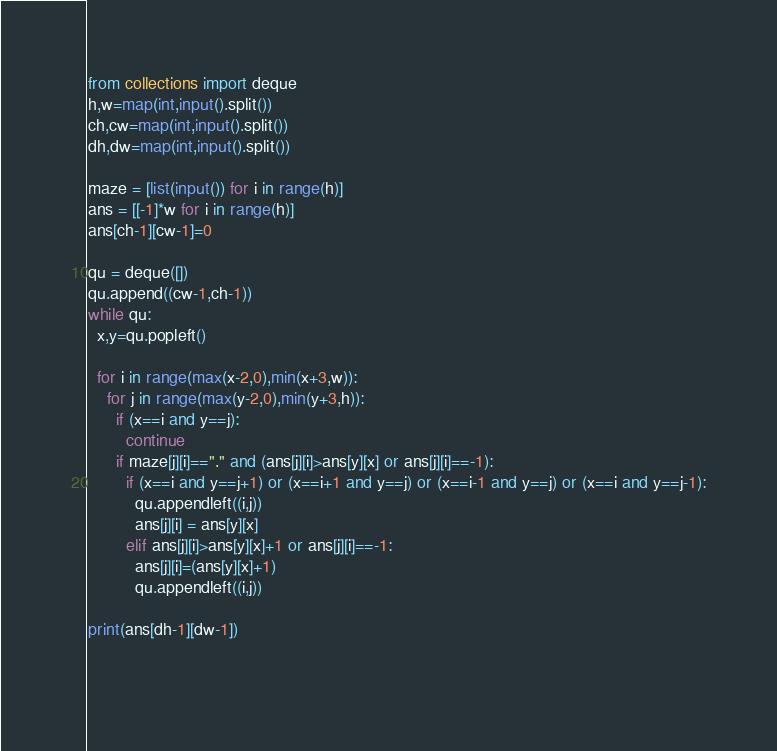<code> <loc_0><loc_0><loc_500><loc_500><_Python_>from collections import deque
h,w=map(int,input().split())
ch,cw=map(int,input().split())
dh,dw=map(int,input().split())

maze = [list(input()) for i in range(h)]
ans = [[-1]*w for i in range(h)]
ans[ch-1][cw-1]=0

qu = deque([])
qu.append((cw-1,ch-1))
while qu:
  x,y=qu.popleft()

  for i in range(max(x-2,0),min(x+3,w)):
    for j in range(max(y-2,0),min(y+3,h)):
      if (x==i and y==j):
        continue
      if maze[j][i]=="." and (ans[j][i]>ans[y][x] or ans[j][i]==-1):
        if (x==i and y==j+1) or (x==i+1 and y==j) or (x==i-1 and y==j) or (x==i and y==j-1):
          qu.appendleft((i,j))
          ans[j][i] = ans[y][x]
        elif ans[j][i]>ans[y][x]+1 or ans[j][i]==-1:
          ans[j][i]=(ans[y][x]+1)
          qu.appendleft((i,j))

print(ans[dh-1][dw-1])

  


</code> 